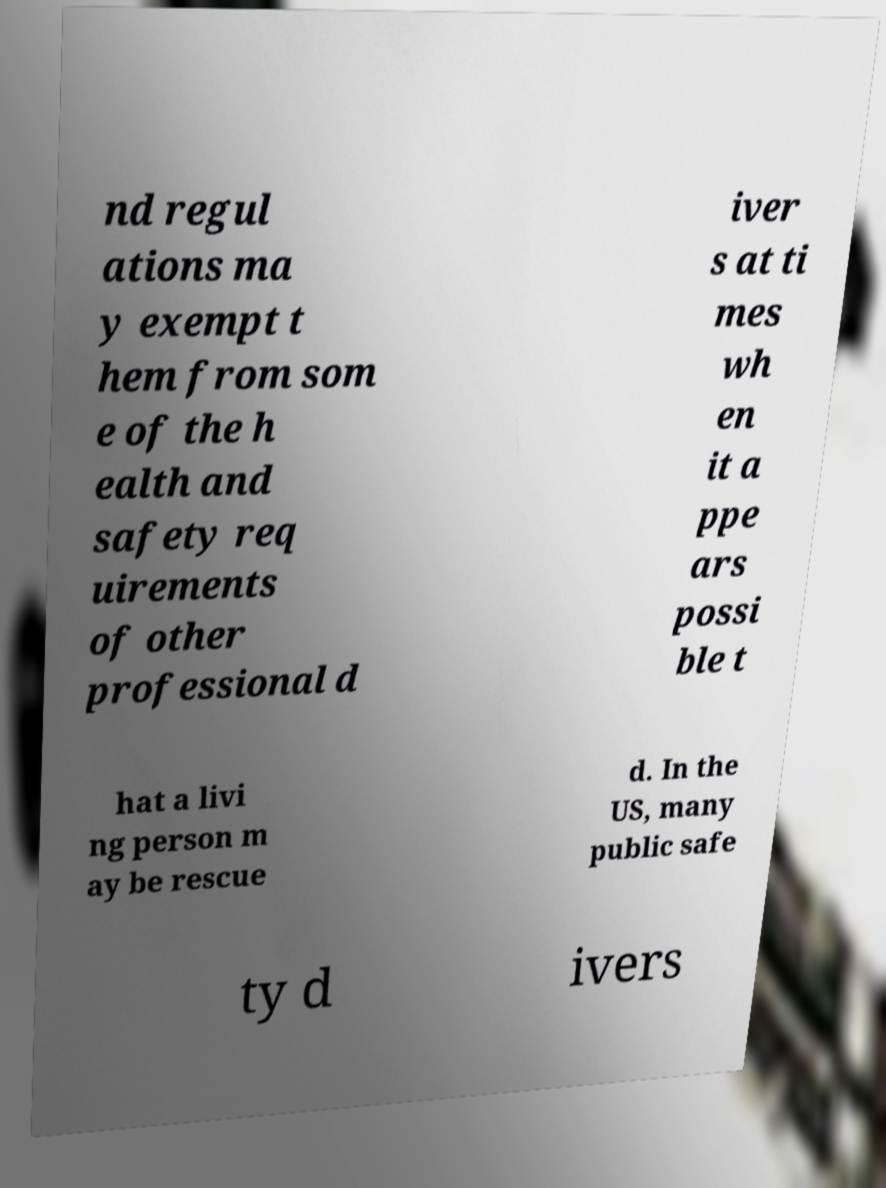I need the written content from this picture converted into text. Can you do that? nd regul ations ma y exempt t hem from som e of the h ealth and safety req uirements of other professional d iver s at ti mes wh en it a ppe ars possi ble t hat a livi ng person m ay be rescue d. In the US, many public safe ty d ivers 